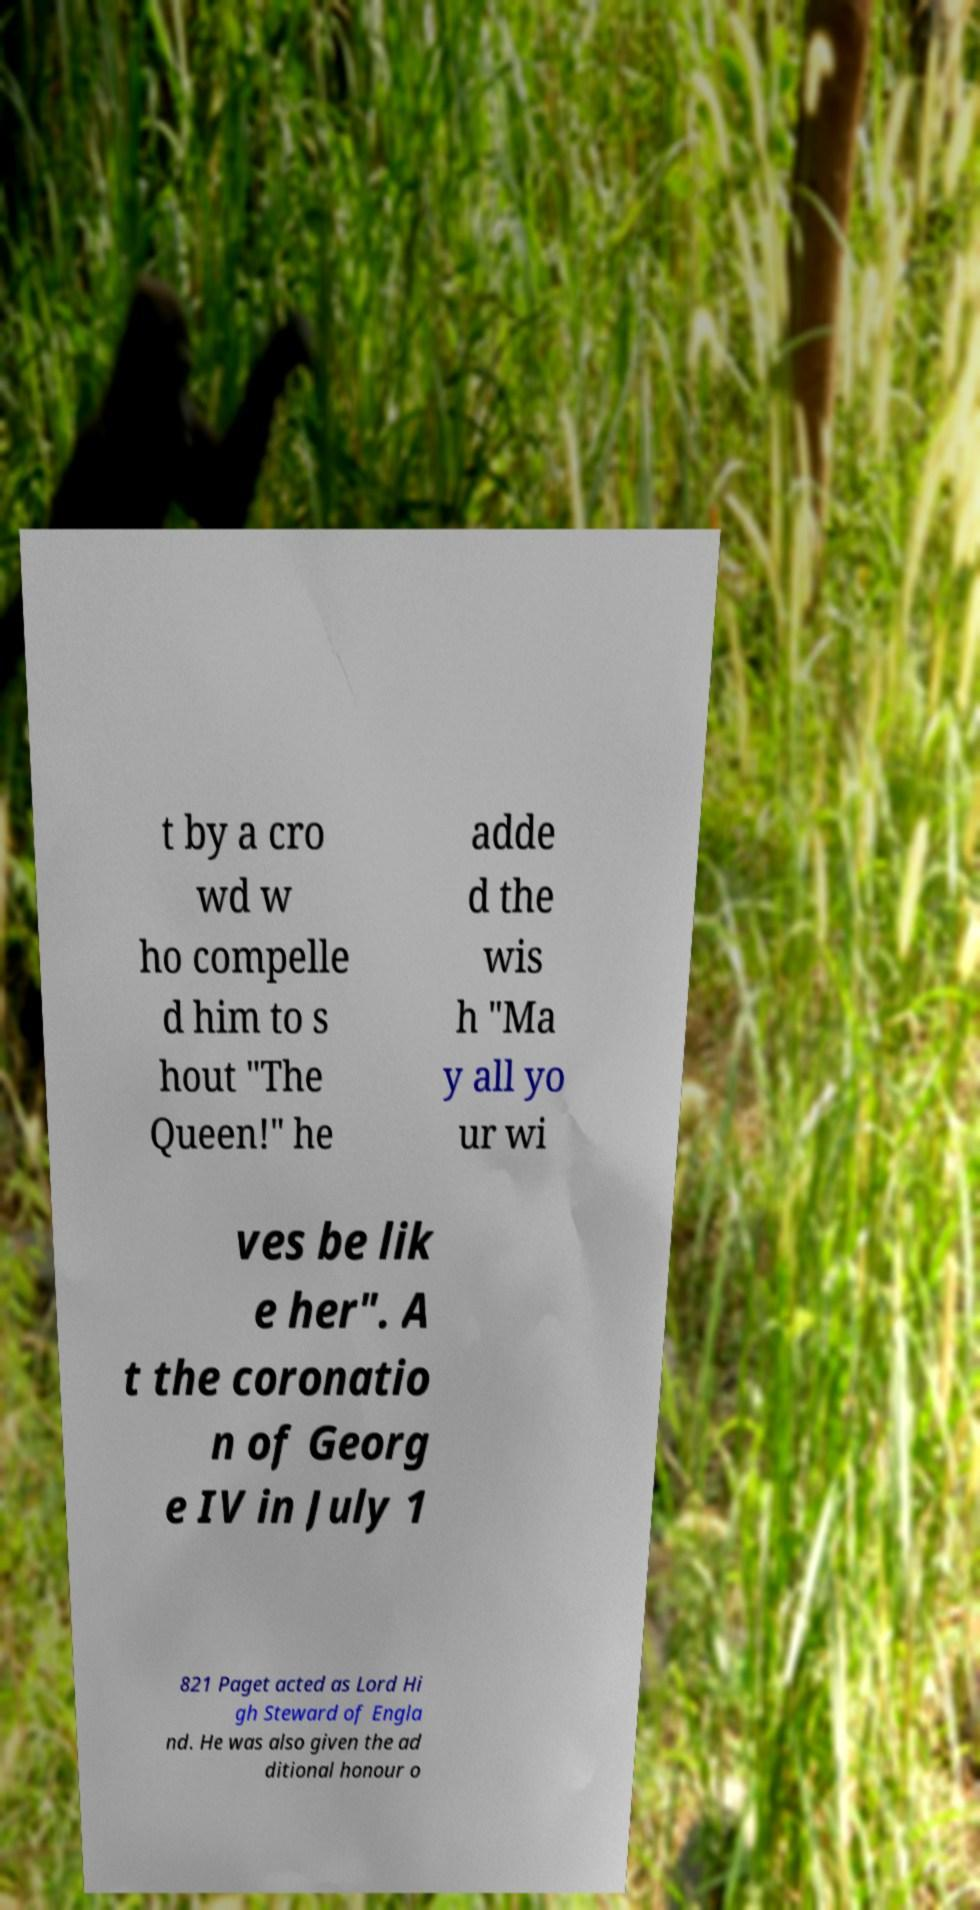Could you extract and type out the text from this image? t by a cro wd w ho compelle d him to s hout "The Queen!" he adde d the wis h "Ma y all yo ur wi ves be lik e her". A t the coronatio n of Georg e IV in July 1 821 Paget acted as Lord Hi gh Steward of Engla nd. He was also given the ad ditional honour o 